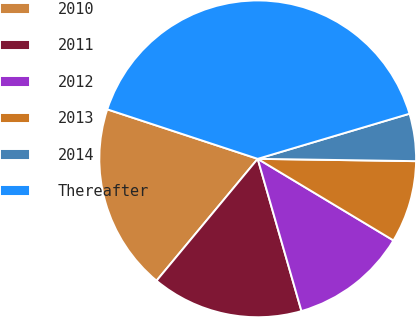Convert chart to OTSL. <chart><loc_0><loc_0><loc_500><loc_500><pie_chart><fcel>2010<fcel>2011<fcel>2012<fcel>2013<fcel>2014<fcel>Thereafter<nl><fcel>19.03%<fcel>15.48%<fcel>11.93%<fcel>8.38%<fcel>4.83%<fcel>40.34%<nl></chart> 